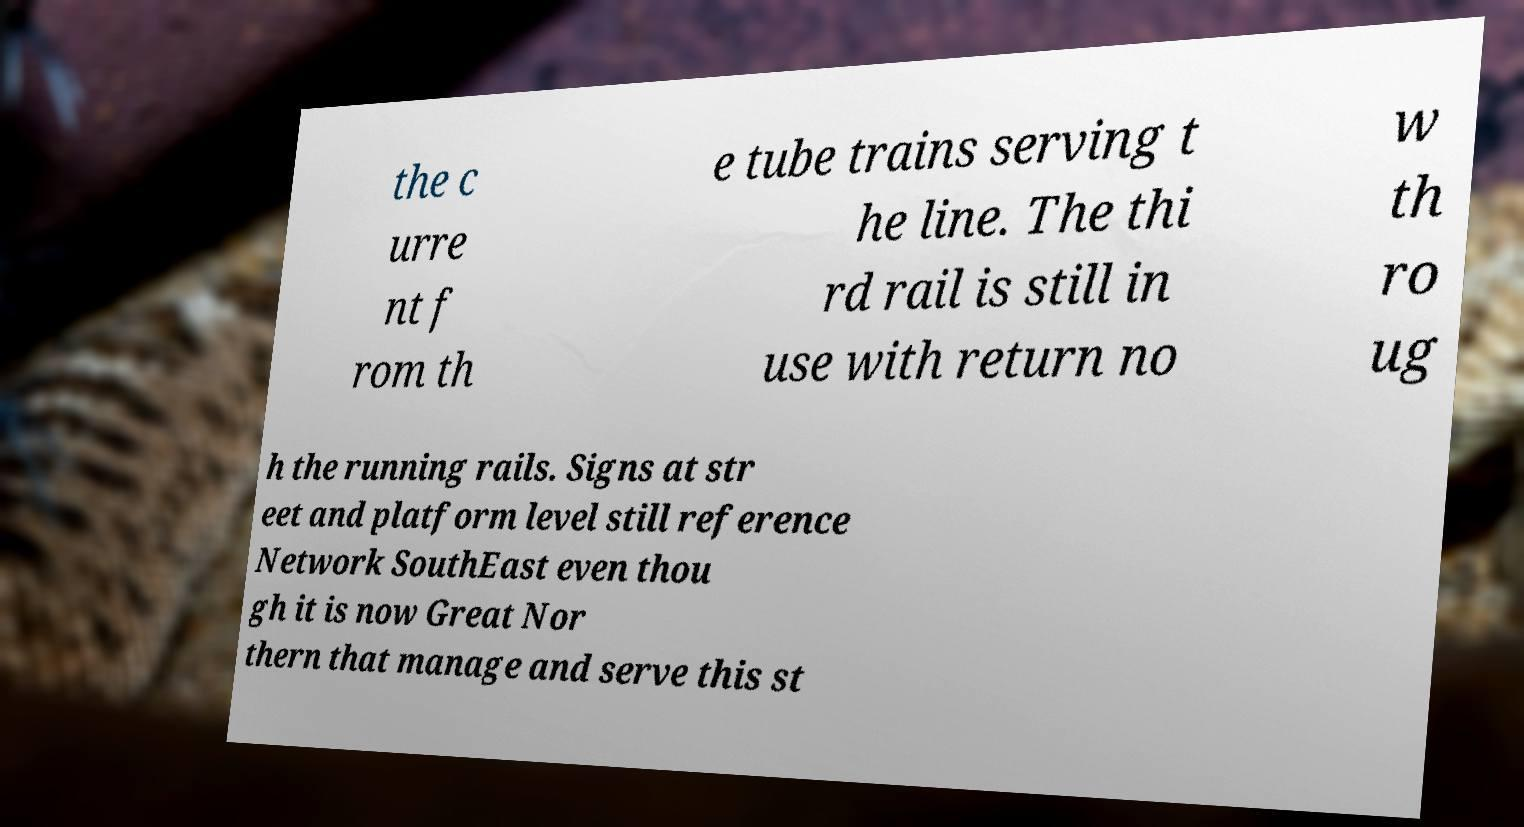Can you read and provide the text displayed in the image?This photo seems to have some interesting text. Can you extract and type it out for me? the c urre nt f rom th e tube trains serving t he line. The thi rd rail is still in use with return no w th ro ug h the running rails. Signs at str eet and platform level still reference Network SouthEast even thou gh it is now Great Nor thern that manage and serve this st 